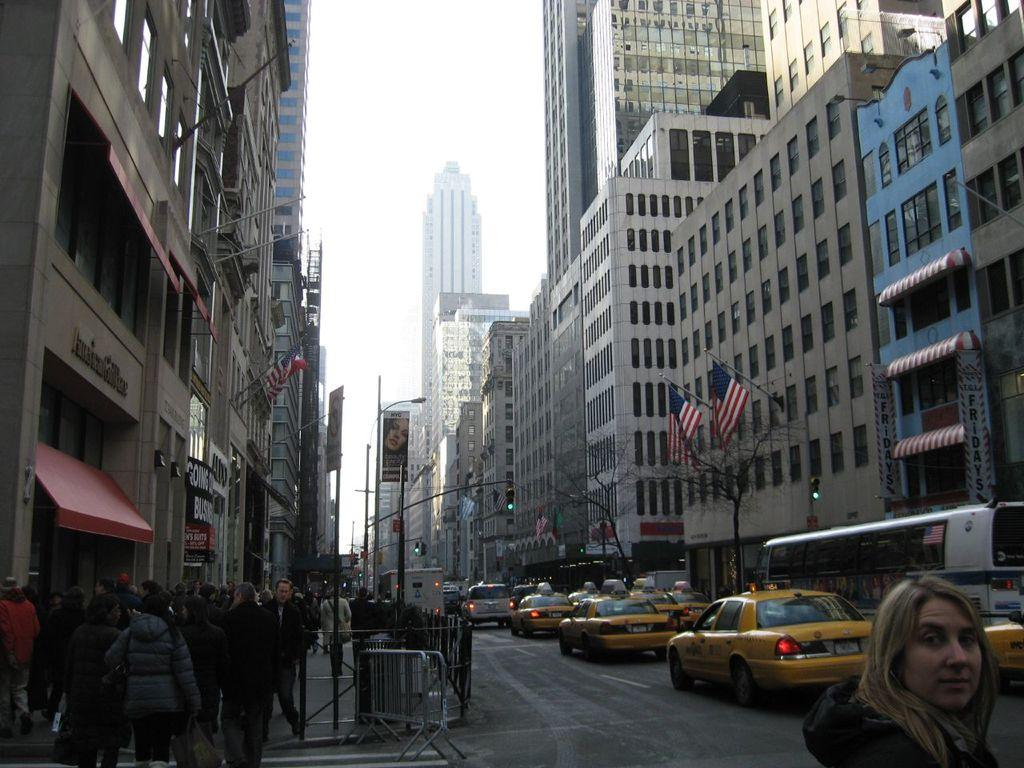<image>
Share a concise interpretation of the image provided. A woman on a street in New York with a sign for TGI FRIDAYS in the background. 